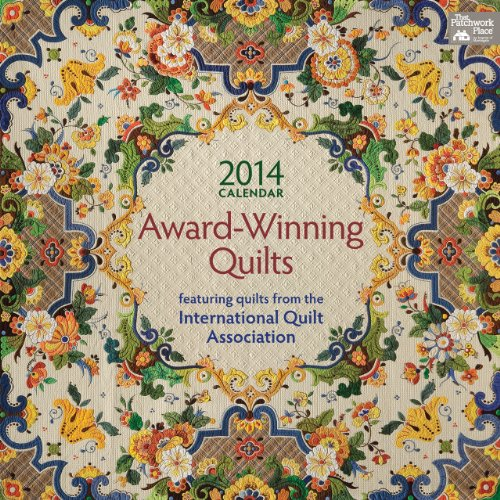What is the year printed on this calendar? The year printed on this calendar, as prominently displayed, is 2014. It includes quilts that were recognized for their excellence that year. 